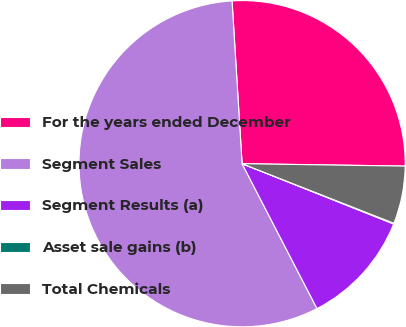Convert chart to OTSL. <chart><loc_0><loc_0><loc_500><loc_500><pie_chart><fcel>For the years ended December<fcel>Segment Sales<fcel>Segment Results (a)<fcel>Asset sale gains (b)<fcel>Total Chemicals<nl><fcel>26.22%<fcel>56.62%<fcel>11.38%<fcel>0.07%<fcel>5.72%<nl></chart> 